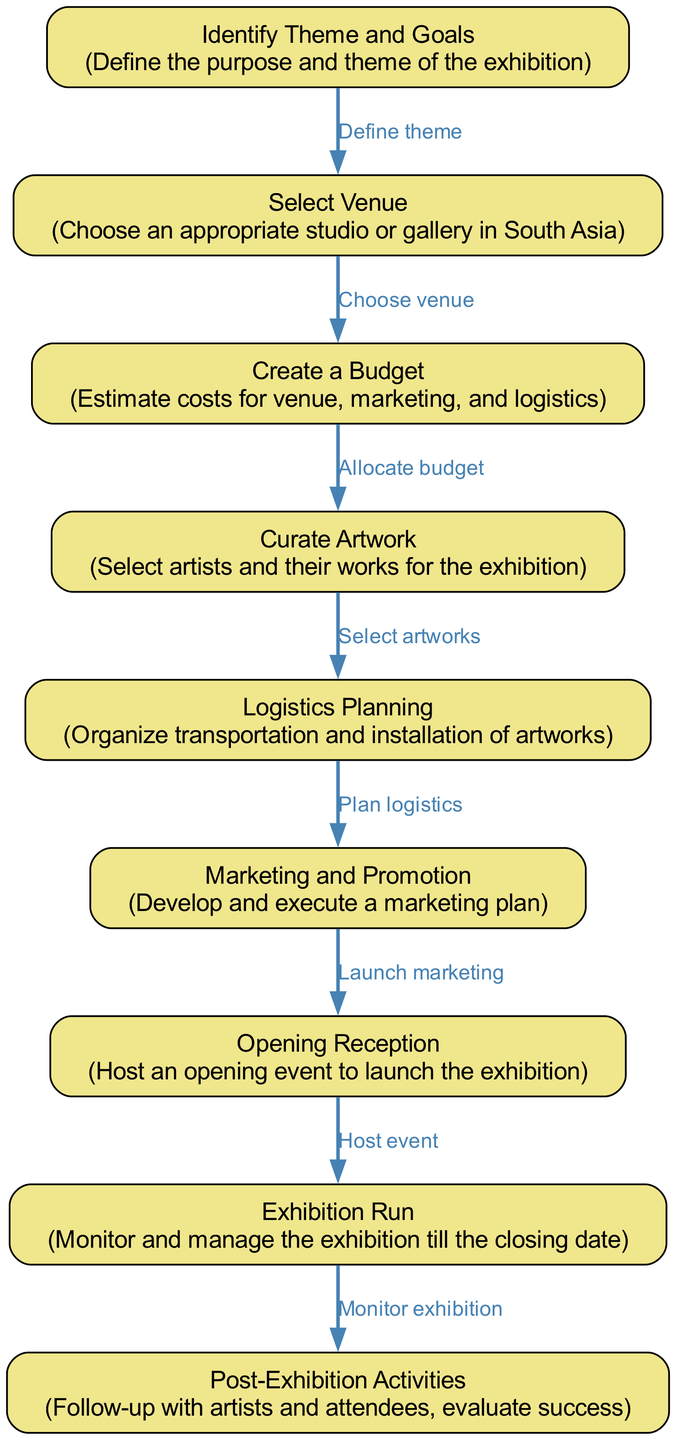What is the first step in the process? The first step is labeled "Identify Theme and Goals," indicating that defining the purpose and theme of the exhibition comes first in the flowchart process.
Answer: Identify Theme and Goals How many nodes are in the diagram? By counting all the nodes listed in the data, there are a total of nine nodes involved in the process of organizing an art exhibition.
Answer: 9 What is the last step in the exhibition process? The last step is labeled "Post-Exhibition Activities," which involves following up with artists and attendees and evaluating the success of the exhibition.
Answer: Post-Exhibition Activities Which node corresponds to planning logistics? The node labeled "Logistics Planning" corresponds directly to the stage where transportation and installation of artworks are organized in the flowchart.
Answer: Logistics Planning What is the relationship between "Marketing and Promotion" and "Opening Reception"? The edge connecting "Marketing and Promotion" to "Opening Reception" indicates that the marketing plan should be executed before hosting the opening event.
Answer: Launch marketing How many edges are present in the diagram? The total number of edges can be counted, which indicates the number of relationships and transitions between the nodes; there are a total of eight edges in the diagram.
Answer: 8 What node follows "Curate Artwork"? The node that follows "Curate Artwork" is "Logistics Planning," as indicated by the directed edge in the flowchart showing the flow from artwork curation to logistics arrangements.
Answer: Logistics Planning What two nodes are connected by the edge labeled "Host event"? The edge labeled "Host event" connects the nodes "Opening Reception" and "Exhibition Run," indicating the sequence of hosting the event and managing the exhibition afterward.
Answer: Opening Reception, Exhibition Run What is the main focus of the "Create a Budget" step? The main focus of the "Create a Budget" step is estimating costs related to the venue, marketing, and logistics for the exhibition as described in the diagram's details.
Answer: Estimate costs 